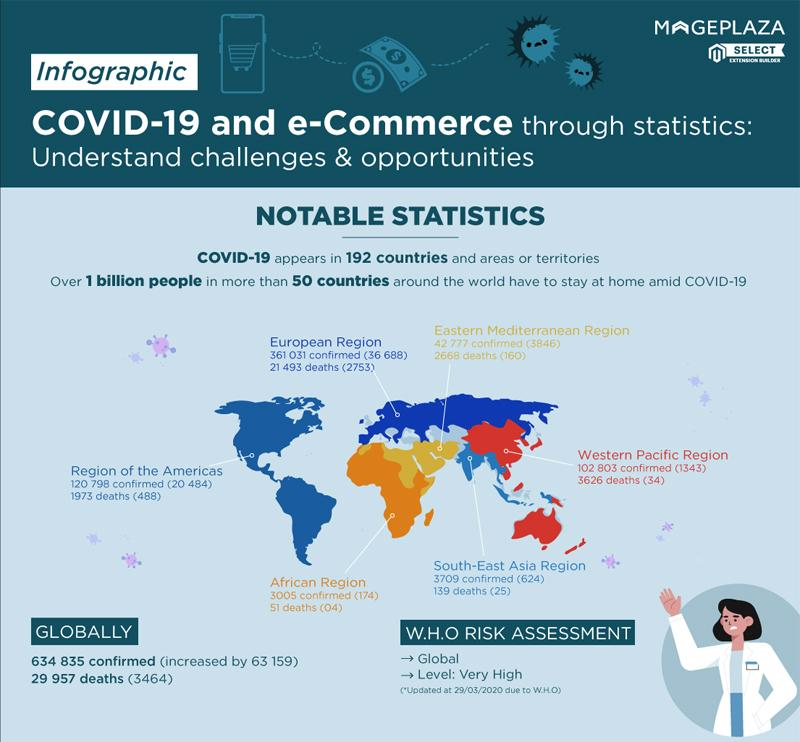Identify some key points in this picture. The number of deaths in Africa is 51. The European region has the highest number of deaths. In the region of the Americas, the number of deaths in 1973 was X. The number of deaths in the Western Pacific region is 3,626. The number of confirmed cases of COVID-19 in South-East Asia is significantly higher than in Africa. 